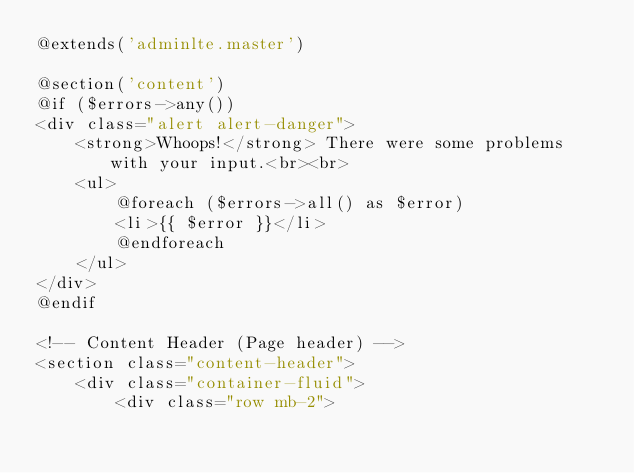Convert code to text. <code><loc_0><loc_0><loc_500><loc_500><_PHP_>@extends('adminlte.master')

@section('content')
@if ($errors->any())
<div class="alert alert-danger">
    <strong>Whoops!</strong> There were some problems with your input.<br><br>
    <ul>
        @foreach ($errors->all() as $error)
        <li>{{ $error }}</li>
        @endforeach
    </ul>
</div>
@endif

<!-- Content Header (Page header) -->
<section class="content-header">
    <div class="container-fluid">
        <div class="row mb-2"></code> 